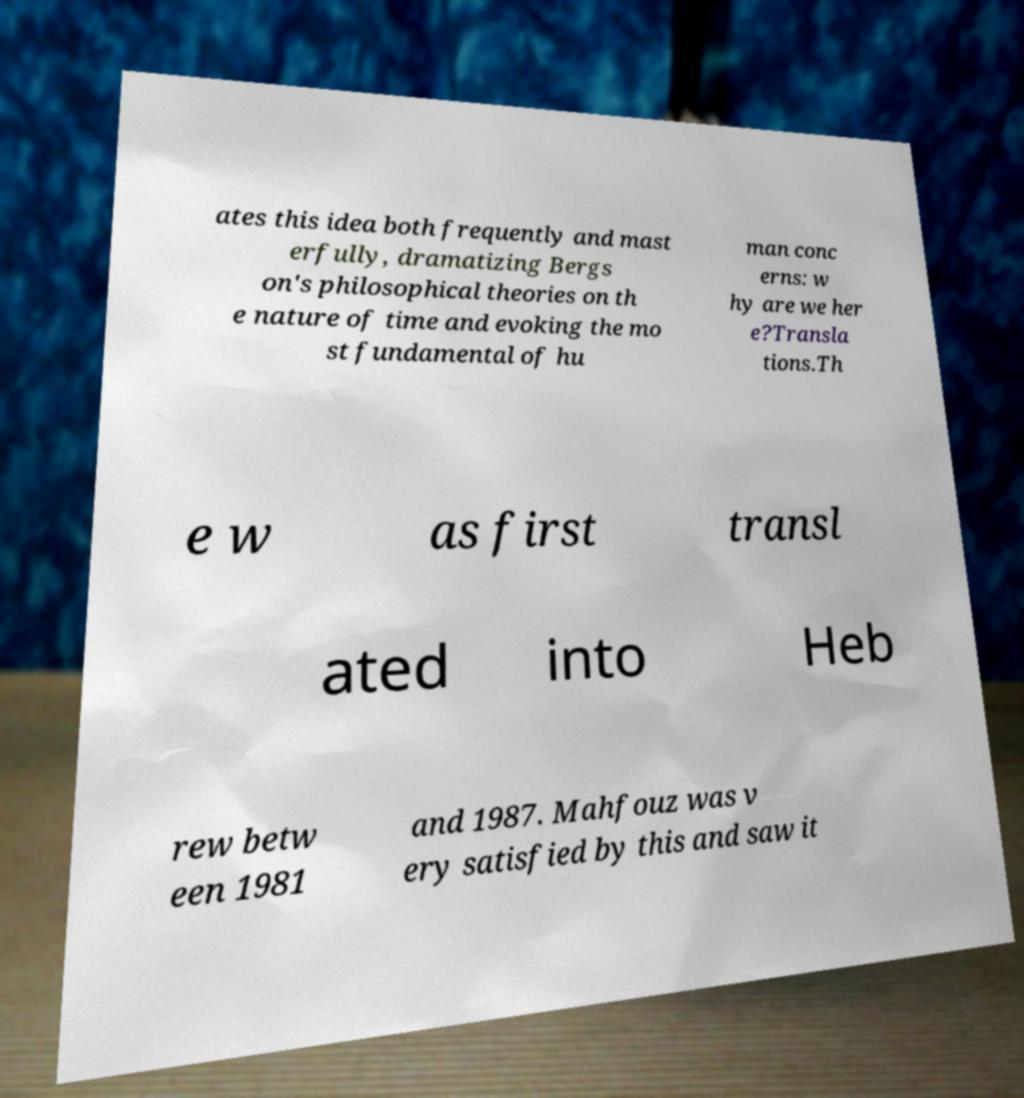Can you accurately transcribe the text from the provided image for me? ates this idea both frequently and mast erfully, dramatizing Bergs on's philosophical theories on th e nature of time and evoking the mo st fundamental of hu man conc erns: w hy are we her e?Transla tions.Th e w as first transl ated into Heb rew betw een 1981 and 1987. Mahfouz was v ery satisfied by this and saw it 